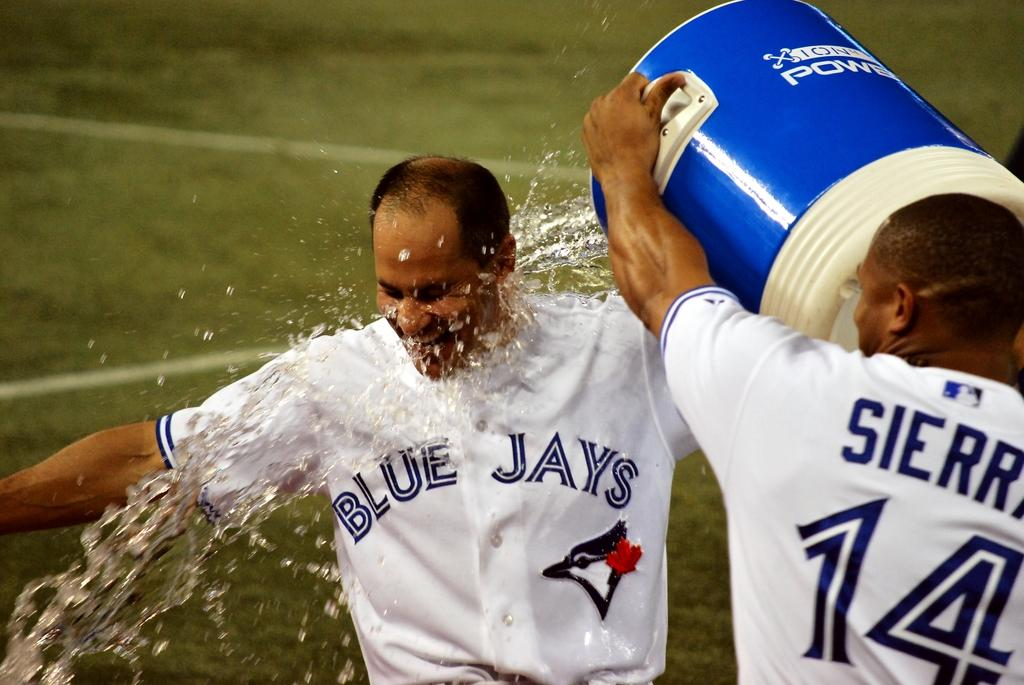Provide a one-sentence caption for the provided image. One blue jays player is getting alot of water poured over them by another player. 